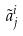Convert formula to latex. <formula><loc_0><loc_0><loc_500><loc_500>\tilde { a } _ { j } ^ { i }</formula> 